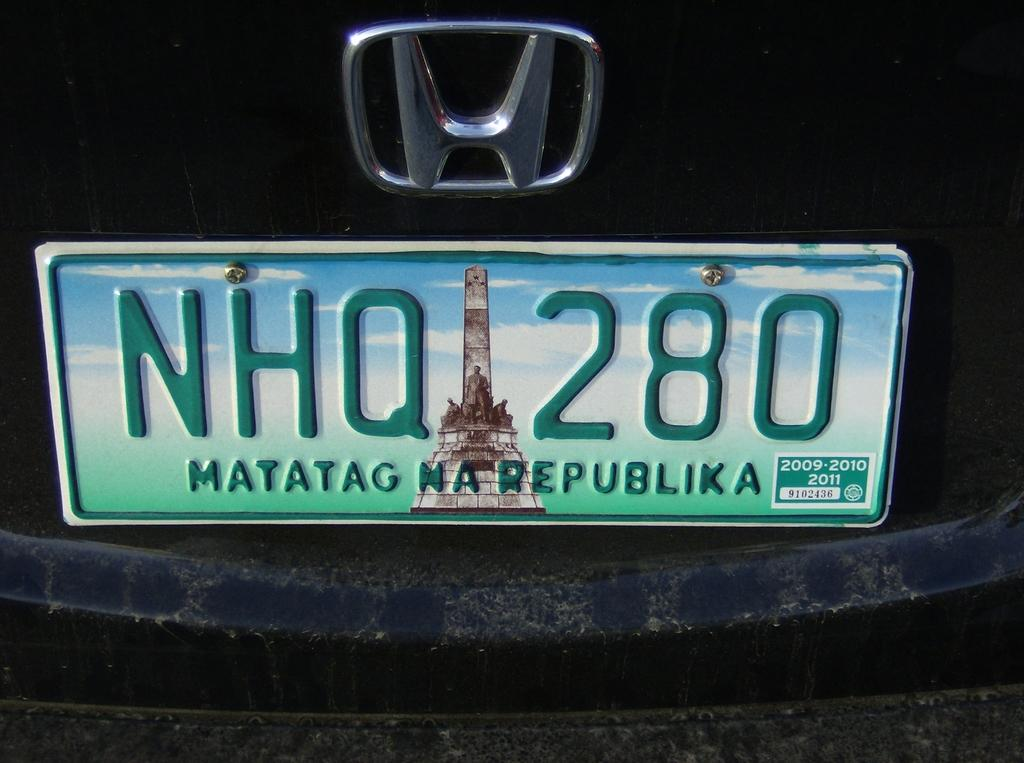<image>
Offer a succinct explanation of the picture presented. A black Honda has a license plate that says Matatag Republika. 